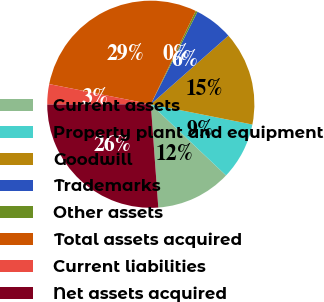<chart> <loc_0><loc_0><loc_500><loc_500><pie_chart><fcel>Current assets<fcel>Property plant and equipment<fcel>Goodwill<fcel>Trademarks<fcel>Other assets<fcel>Total assets acquired<fcel>Current liabilities<fcel>Net assets acquired<nl><fcel>11.79%<fcel>8.92%<fcel>14.66%<fcel>6.04%<fcel>0.3%<fcel>29.02%<fcel>3.17%<fcel>26.1%<nl></chart> 